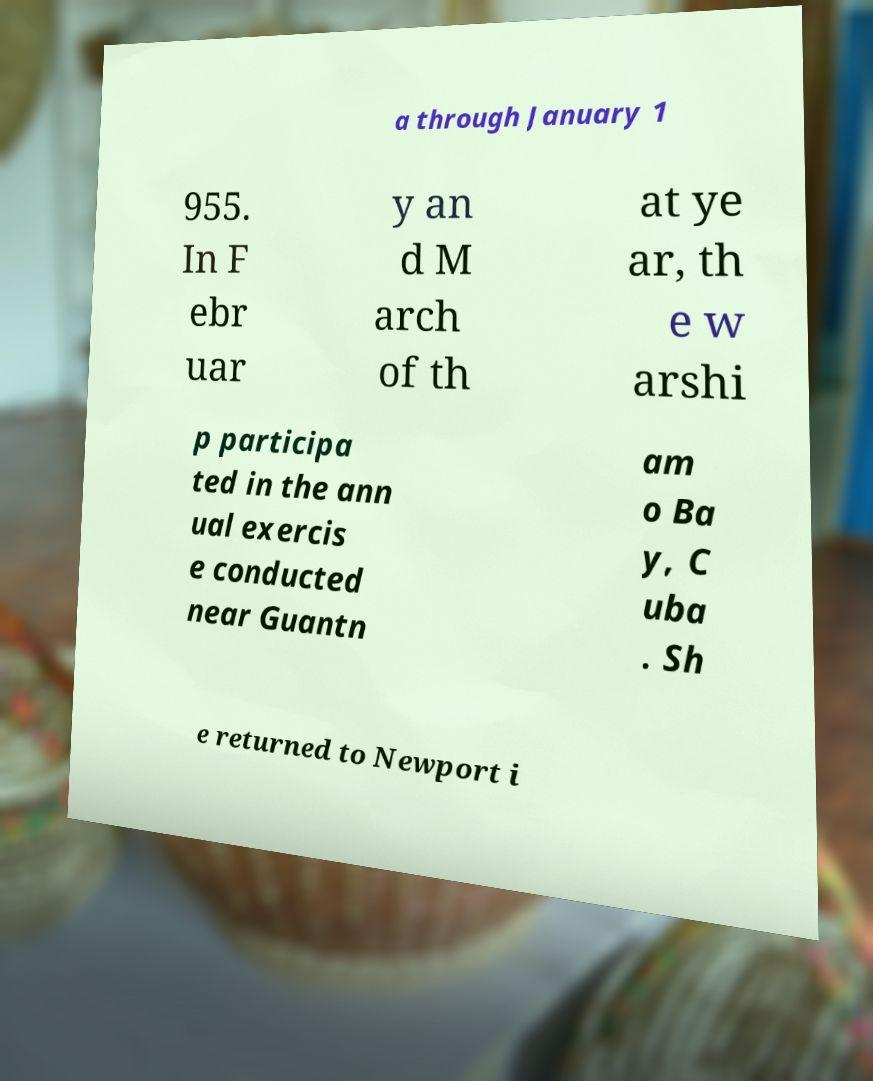I need the written content from this picture converted into text. Can you do that? a through January 1 955. In F ebr uar y an d M arch of th at ye ar, th e w arshi p participa ted in the ann ual exercis e conducted near Guantn am o Ba y, C uba . Sh e returned to Newport i 